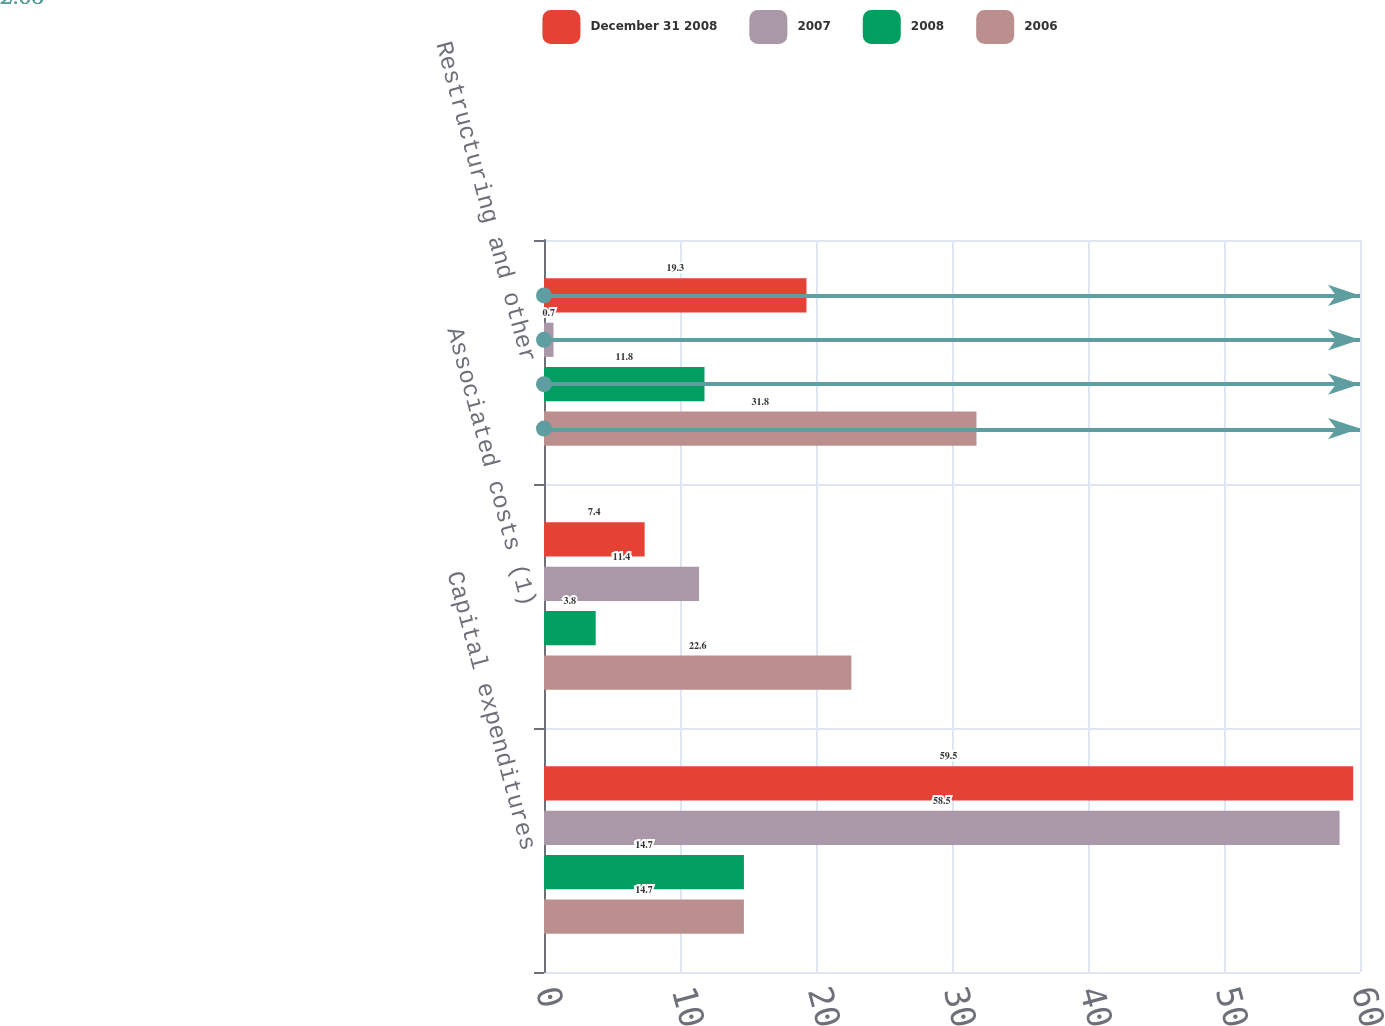Convert chart to OTSL. <chart><loc_0><loc_0><loc_500><loc_500><stacked_bar_chart><ecel><fcel>Capital expenditures<fcel>Associated costs (1)<fcel>Restructuring and other<nl><fcel>December 31 2008<fcel>59.5<fcel>7.4<fcel>19.3<nl><fcel>2007<fcel>58.5<fcel>11.4<fcel>0.7<nl><fcel>2008<fcel>14.7<fcel>3.8<fcel>11.8<nl><fcel>2006<fcel>14.7<fcel>22.6<fcel>31.8<nl></chart> 